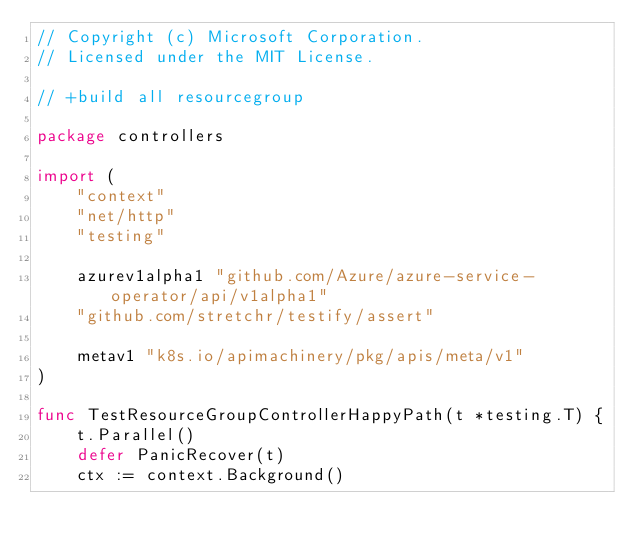Convert code to text. <code><loc_0><loc_0><loc_500><loc_500><_Go_>// Copyright (c) Microsoft Corporation.
// Licensed under the MIT License.

// +build all resourcegroup

package controllers

import (
	"context"
	"net/http"
	"testing"

	azurev1alpha1 "github.com/Azure/azure-service-operator/api/v1alpha1"
	"github.com/stretchr/testify/assert"

	metav1 "k8s.io/apimachinery/pkg/apis/meta/v1"
)

func TestResourceGroupControllerHappyPath(t *testing.T) {
	t.Parallel()
	defer PanicRecover(t)
	ctx := context.Background()</code> 